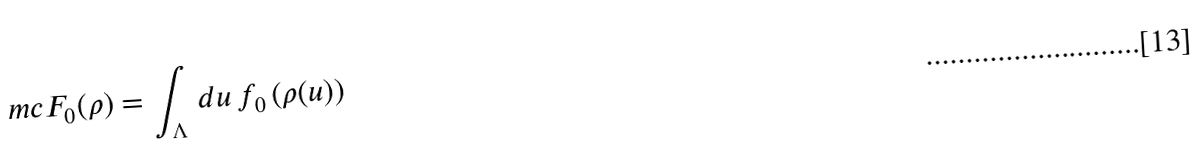Convert formula to latex. <formula><loc_0><loc_0><loc_500><loc_500>\ m c F _ { 0 } ( \rho ) = \int _ { \Lambda } \, d u \, f _ { 0 } \left ( \rho ( u ) \right )</formula> 